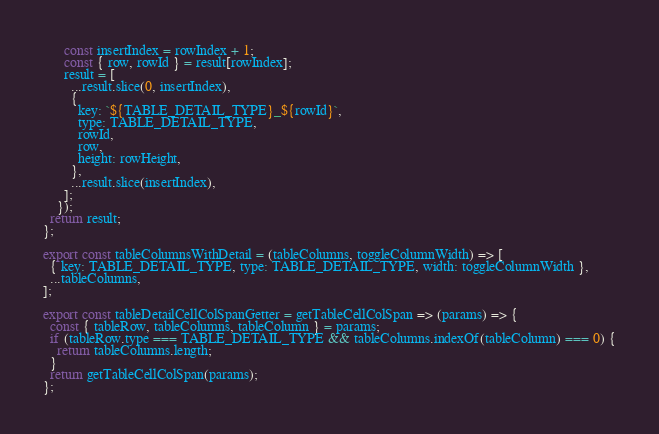<code> <loc_0><loc_0><loc_500><loc_500><_JavaScript_>      const insertIndex = rowIndex + 1;
      const { row, rowId } = result[rowIndex];
      result = [
        ...result.slice(0, insertIndex),
        {
          key: `${TABLE_DETAIL_TYPE}_${rowId}`,
          type: TABLE_DETAIL_TYPE,
          rowId,
          row,
          height: rowHeight,
        },
        ...result.slice(insertIndex),
      ];
    });
  return result;
};

export const tableColumnsWithDetail = (tableColumns, toggleColumnWidth) => [
  { key: TABLE_DETAIL_TYPE, type: TABLE_DETAIL_TYPE, width: toggleColumnWidth },
  ...tableColumns,
];

export const tableDetailCellColSpanGetter = getTableCellColSpan => (params) => {
  const { tableRow, tableColumns, tableColumn } = params;
  if (tableRow.type === TABLE_DETAIL_TYPE && tableColumns.indexOf(tableColumn) === 0) {
    return tableColumns.length;
  }
  return getTableCellColSpan(params);
};
</code> 